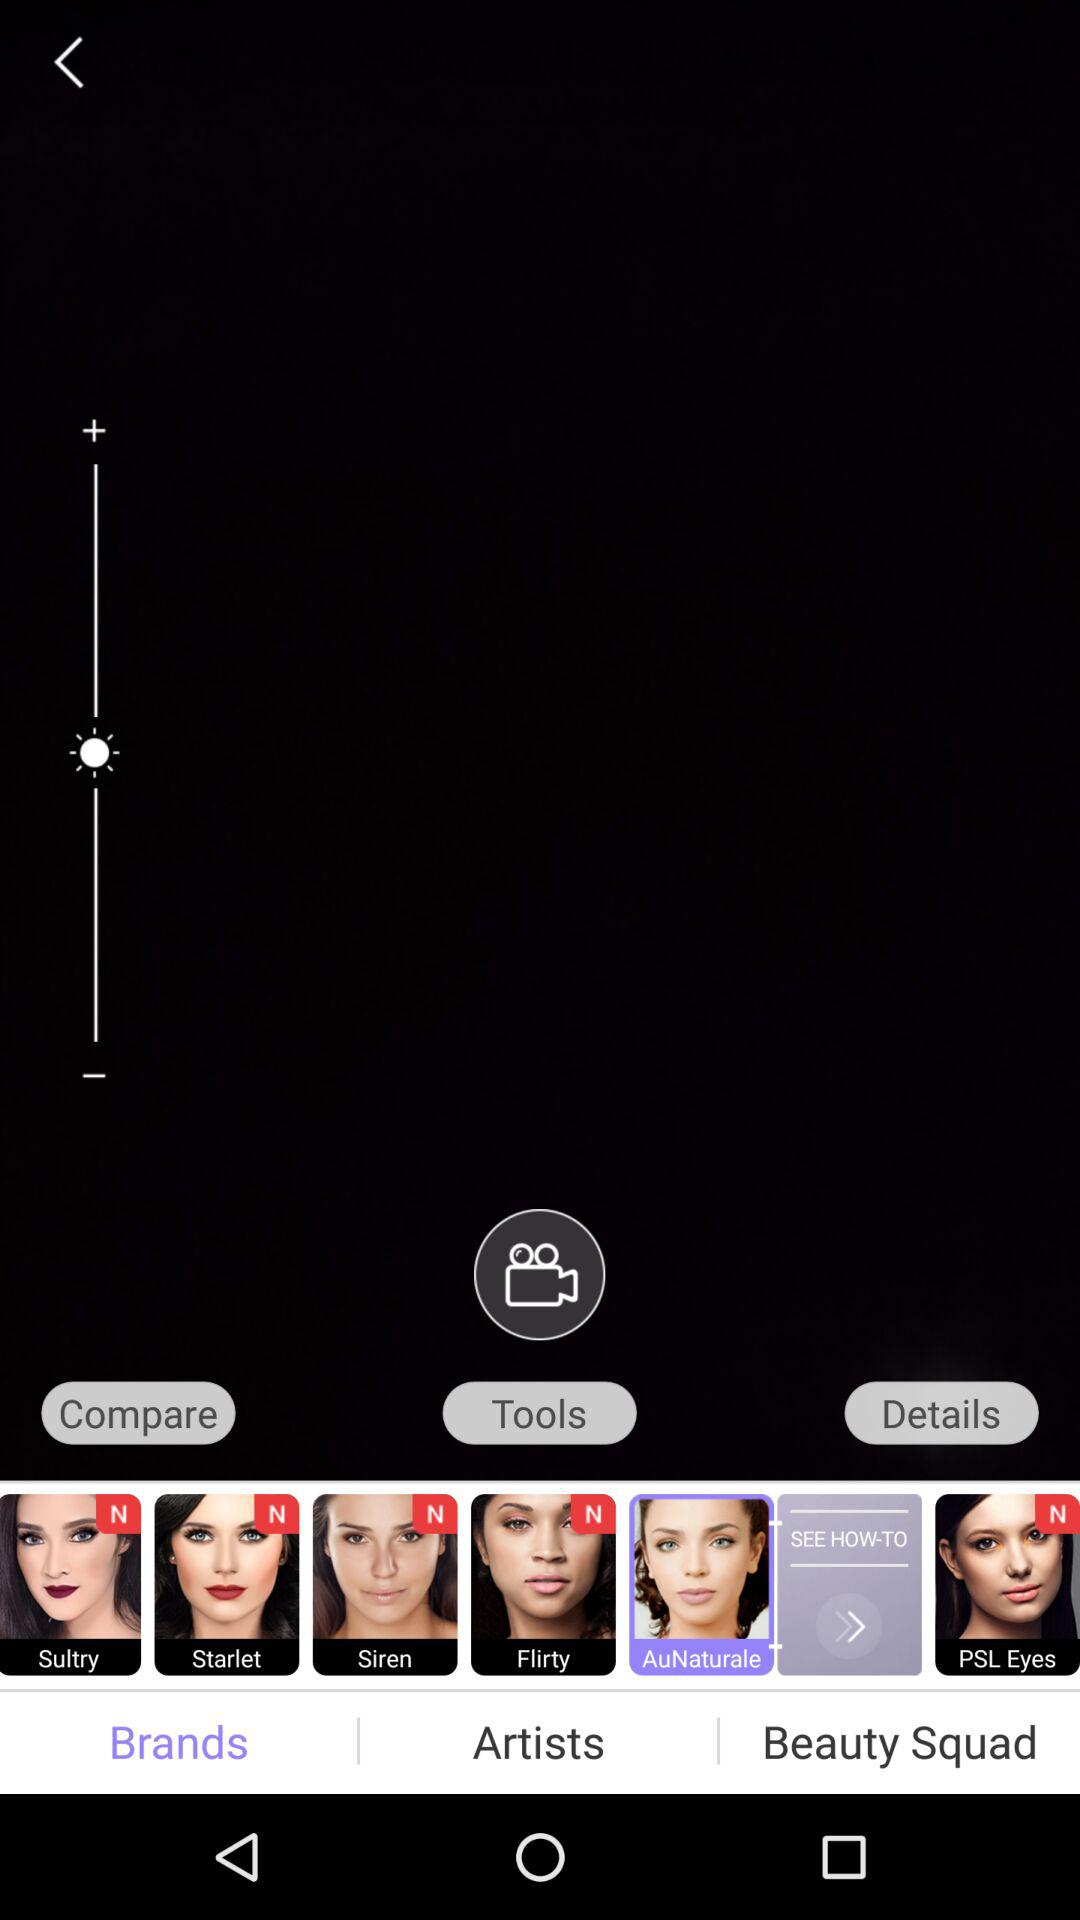How many makeup looks are there?
Answer the question using a single word or phrase. 6 